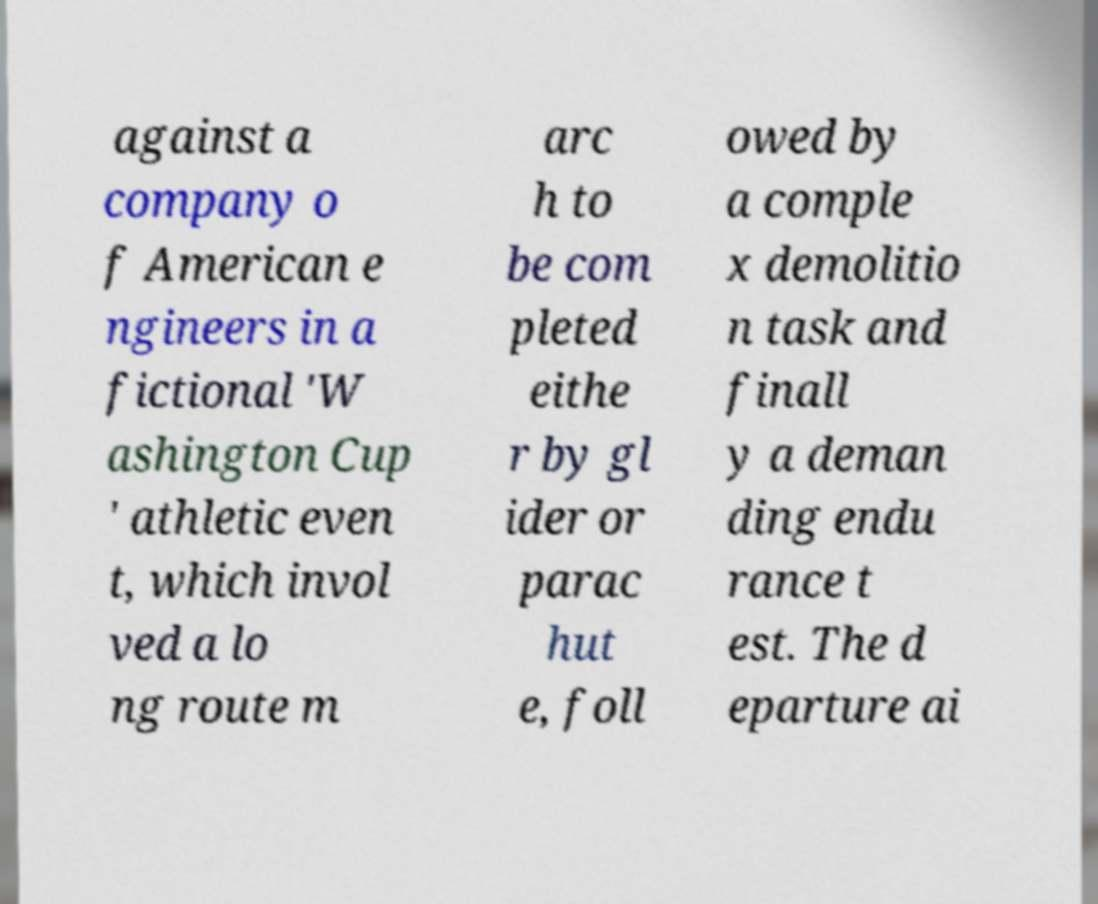Could you assist in decoding the text presented in this image and type it out clearly? against a company o f American e ngineers in a fictional 'W ashington Cup ' athletic even t, which invol ved a lo ng route m arc h to be com pleted eithe r by gl ider or parac hut e, foll owed by a comple x demolitio n task and finall y a deman ding endu rance t est. The d eparture ai 